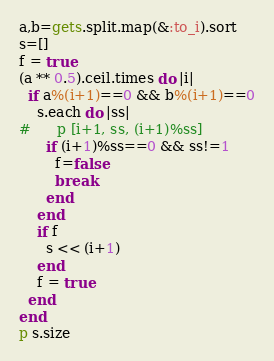Convert code to text. <code><loc_0><loc_0><loc_500><loc_500><_Ruby_>a,b=gets.split.map(&:to_i).sort
s=[]
f = true
(a ** 0.5).ceil.times do |i|
  if a%(i+1)==0 && b%(i+1)==0
    s.each do |ss|
#      p [i+1, ss, (i+1)%ss]
      if (i+1)%ss==0 && ss!=1
        f=false
        break
      end
    end
    if f
      s << (i+1)
    end
    f = true
  end
end
p s.size</code> 